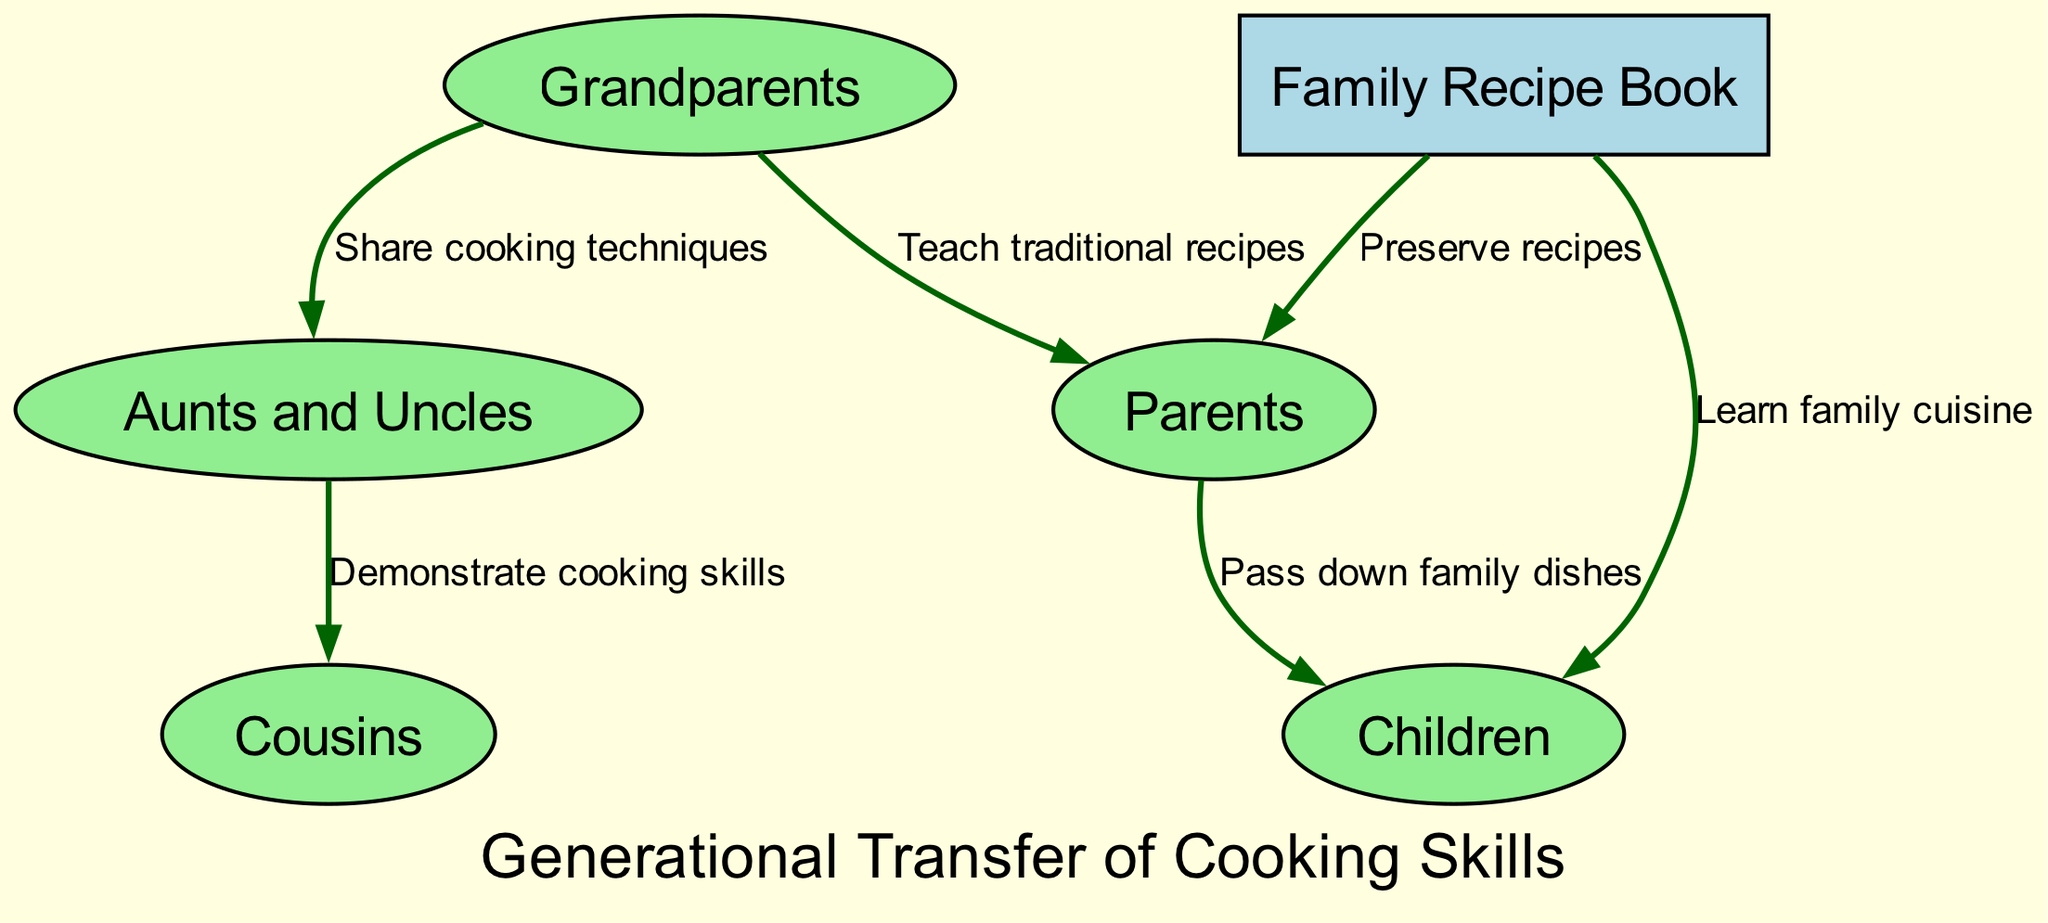What is the total number of nodes in the diagram? The diagram consists of six nodes: Grandparents, Parents, Aunts and Uncles, Cousins, Children, and Family Recipe Book. Counting them gives a total of six nodes.
Answer: 6 What is the relationship between Grandparents and Parents? The edge connecting Grandparents to Parents is labeled "Teach traditional recipes," indicating the action taking place in this relationship.
Answer: Teach traditional recipes How many edges are present in the diagram? There are a total of six edges between the nodes in the diagram. These edges represent different relationships based on cooking skills.
Answer: 6 Which node is used to preserve recipes? The Family Recipe Book is connected to the Parents with the label "Preserve recipes," signifying its role in storing family recipes for future generations.
Answer: Family Recipe Book Who passes down family dishes to Children? The edge pointing from Parents to Children is labeled "Pass down family dishes," indicating that it is the Parents who transfer this knowledge.
Answer: Parents What action do Aunts and Uncles perform with Cousins? The Aunts and Uncles demonstrate cooking skills to Cousins, as indicated by the label on the edge between these nodes.
Answer: Demonstrate cooking skills Which node benefits both Parents and Children? The Family Recipe Book benefits both Parents and Children, as it is connected to both with edges indicating the preservation of recipes and learning family cuisine.
Answer: Family Recipe Book What is the primary source of cooking techniques in the family? The Grandparents are identified as the source of cooking techniques since they share cooking techniques with Aunts and Uncles.
Answer: Grandparents How is the Family Recipe Book related to Children? The Family Recipe Book is connected to Children with the label "Learn family cuisine," showing that Children learn recipes from this source.
Answer: Learn family cuisine 